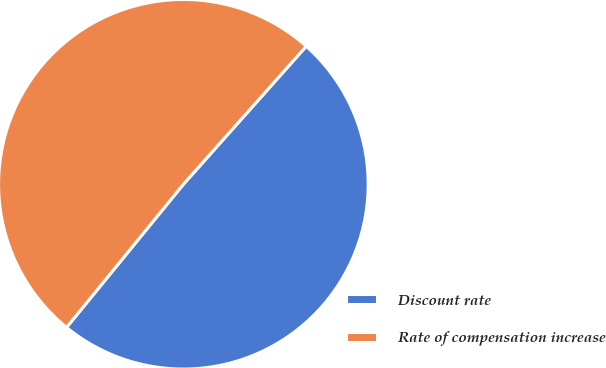Convert chart to OTSL. <chart><loc_0><loc_0><loc_500><loc_500><pie_chart><fcel>Discount rate<fcel>Rate of compensation increase<nl><fcel>49.32%<fcel>50.68%<nl></chart> 